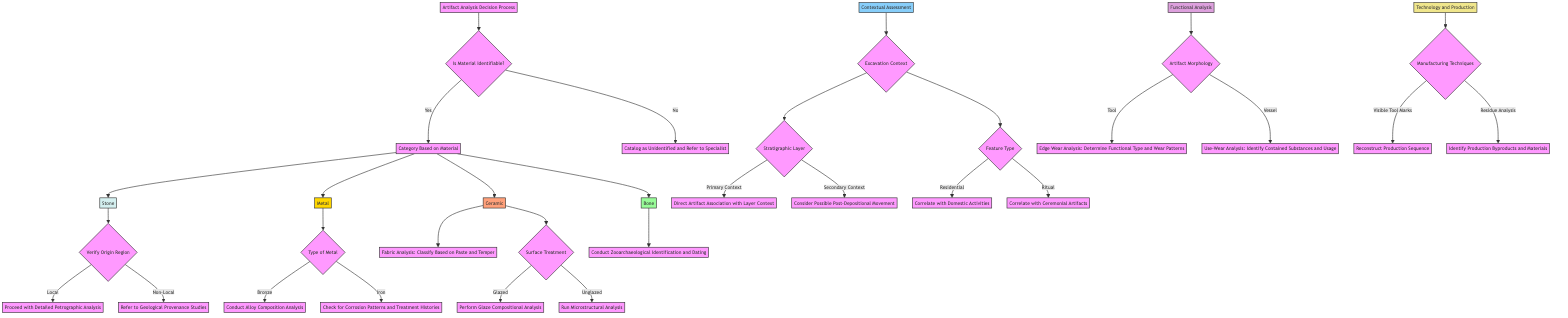What happens if the material is identifiable? If the material is identifiable, the process continues to categorize the artifact based on its material type: Stone, Metal, Ceramic, or Bone.
Answer: Proceed to categorize What should be done if the material is identified as Bone? If the material is identified as Bone, the next step is to conduct Zooarchaeological Identification and Dating.
Answer: Conduct Zooarchaeological Identification and Dating What analysis is performed for Glazed ceramics? For Glazed ceramics, the analysis performed is Glaze Compositional Analysis.
Answer: Perform Glaze Compositional Analysis How many main categories are there after identifying the material? After identifying the material, there are four main categories: Stone, Metal, Ceramic, and Bone.
Answer: Four What do you need to verify after identifying the material as Stone? After identifying the material as Stone, you need to verify the Origin Region, determining if it is Local or Non-Local.
Answer: Verify Origin Region What should be analyzed for Iron metal artifacts? For Iron metal artifacts, the analysis should check for Corrosion Patterns and Treatment Histories.
Answer: Check for Corrosion Patterns and Treatment Histories What does Primary Context in Excavation Context lead to? Primary Context leads to Direct Artifact Association with Layer Context.
Answer: Direct Artifact Association with Layer Context Which analysis helps identify contained substances in vessels? The analysis that helps identify contained substances in vessels is Use-Wear Analysis.
Answer: Use-Wear Analysis What technique helps reconstruct the production sequence? The technique that helps reconstruct the production sequence is Visible Tool Marks analysis.
Answer: Reconstruct Production Sequence 